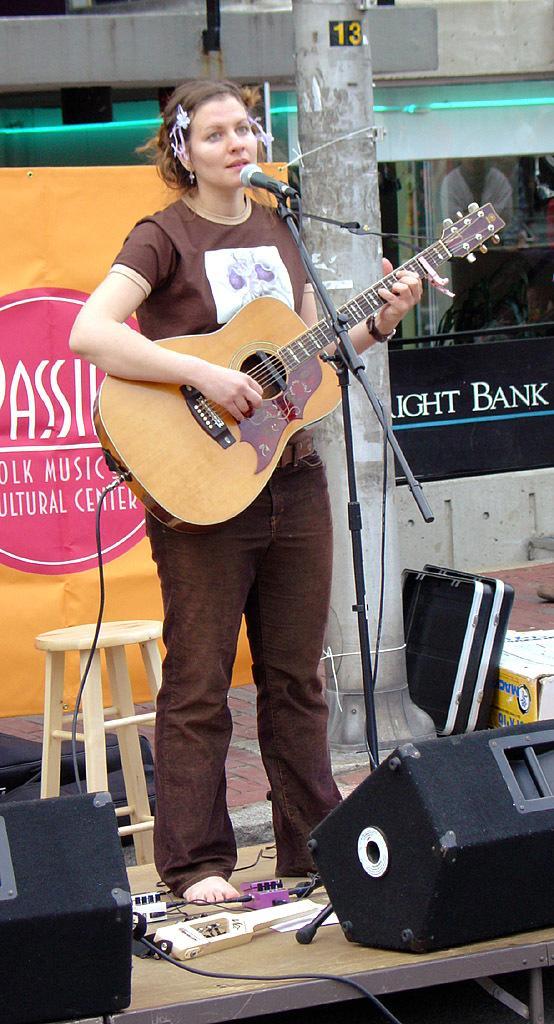Describe this image in one or two sentences. This picture shows there is a woman singing on the floor and playing the guitar 